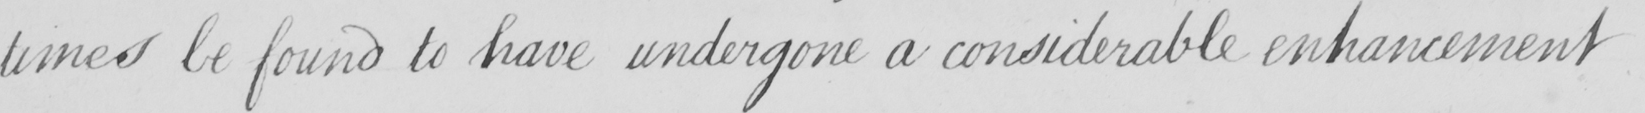Can you read and transcribe this handwriting? times be found to have undergone a considerable enhancement 